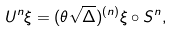<formula> <loc_0><loc_0><loc_500><loc_500>U ^ { n } \xi = ( \theta \sqrt { \Delta } ) ^ { ( n ) } \xi \circ S ^ { n } ,</formula> 